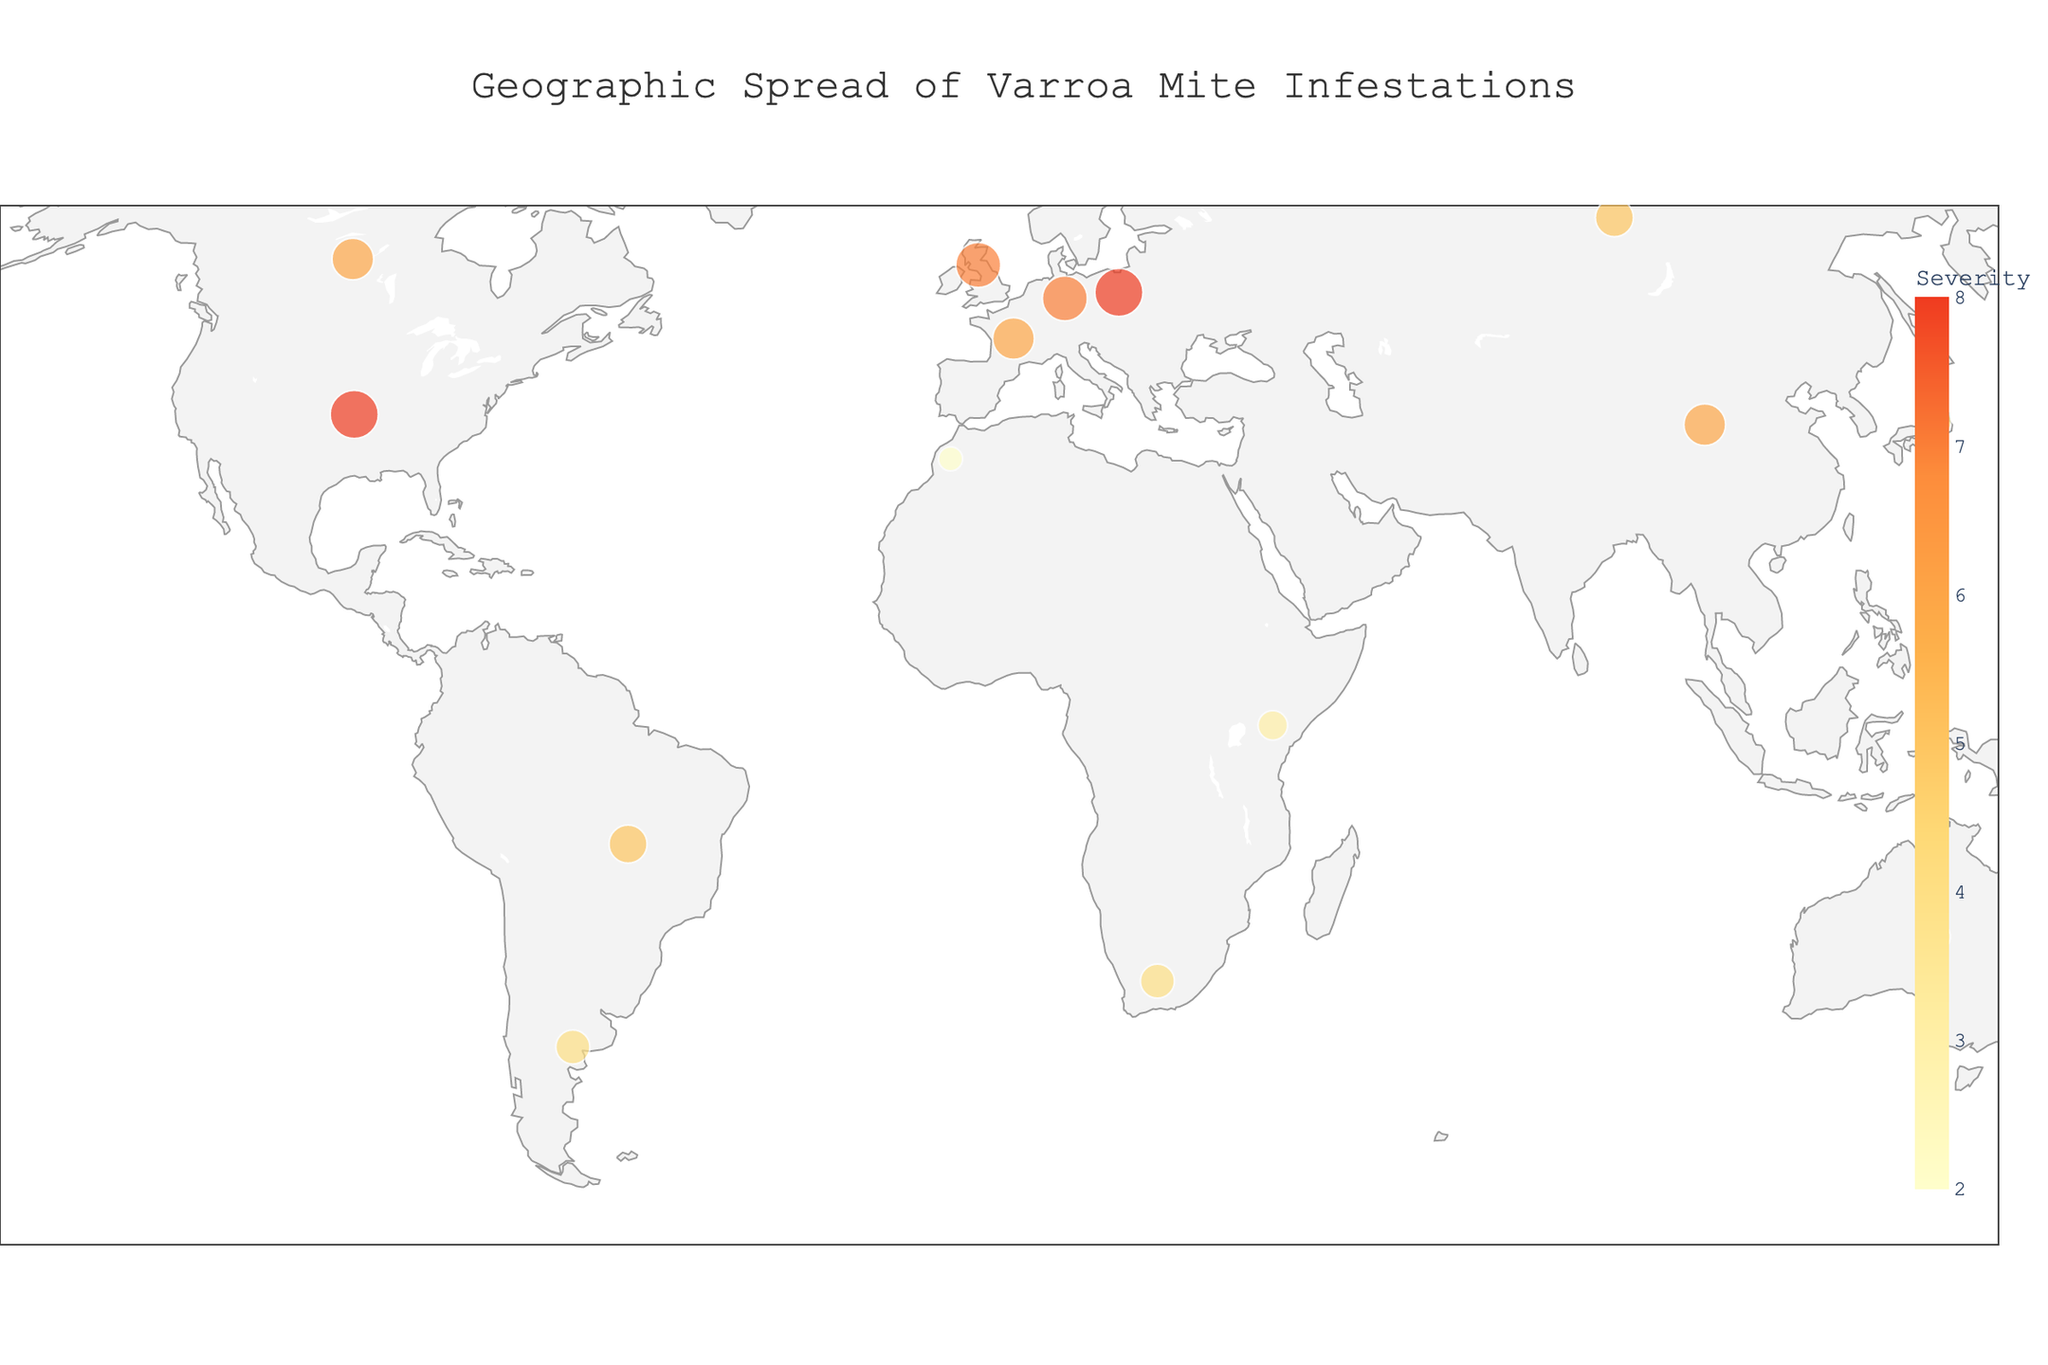How many countries are displayed on the map? Count the total number of countries shown on the plot.
Answer: 15 What is the severity level of the Varroa mite infestation in Poland? Look for Poland on the map and note the color code or size of the circle.
Answer: 8 Compare the severity levels of the Varroa mite infestations between North America and Oceania. Which continent has a higher average severity? Calculate the average severity for North America (United States: 8, Canada: 6) and Oceania (Australia: 3, New Zealand: 5). North America: (8+6)/2 = 7, Oceania: (3+5)/2 = 4.
Answer: North America Which country in Europe has the highest severity of Varroa mite infestation? Look for the countries in Europe on the map and compare their severity levels.
Answer: Poland Is the Severity level higher in Brazil or in South Africa? Compare the severity value indicated for Brazil and South Africa.
Answer: Brazil What is the color of the regions with the highest severity level? Identify the color used for the highest severity level on the map's color scale.
Answer: Dark red Which country in Africa has the lowest level of Varroa mite infestation? Compare the severity levels of Morocco, Kenya, and South Africa.
Answer: Morocco How does the Varroa mite infestation severity in Japan compare to that in Argentina? Compare the severity values for Japan and Argentina.
Answer: Japan is lower What is the average severity level of Varroa mite infestations in Europe? Calculate the average severity for the countries in Europe (United Kingdom: 7, France: 6, Germany: 7, Poland: 8, Russia: 5). (7+6+7+8+5)/5 = 33/5
Answer: 6.6 Which continent has the widest geographic spread of Varroa mite infestations? Look for the continent that spans the most significant latitude and longitude ranges.
Answer: Europe 